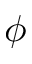<formula> <loc_0><loc_0><loc_500><loc_500>\phi</formula> 